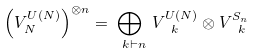Convert formula to latex. <formula><loc_0><loc_0><loc_500><loc_500>\left ( V ^ { U ( N ) } _ { N } \right ) ^ { \otimes n } = \bigoplus _ { \ k \vdash n } \, V _ { \ k } ^ { U ( N ) } \otimes V _ { \ k } ^ { S _ { n } }</formula> 